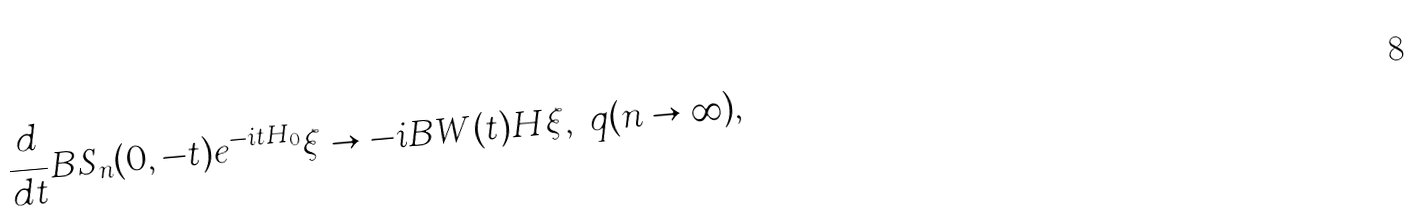<formula> <loc_0><loc_0><loc_500><loc_500>\frac { d } { d t } B S _ { n } ( 0 , - t ) e ^ { - i t H _ { 0 } } \xi \to - i B W ( t ) H \xi , \ q ( n \to \infty ) ,</formula> 